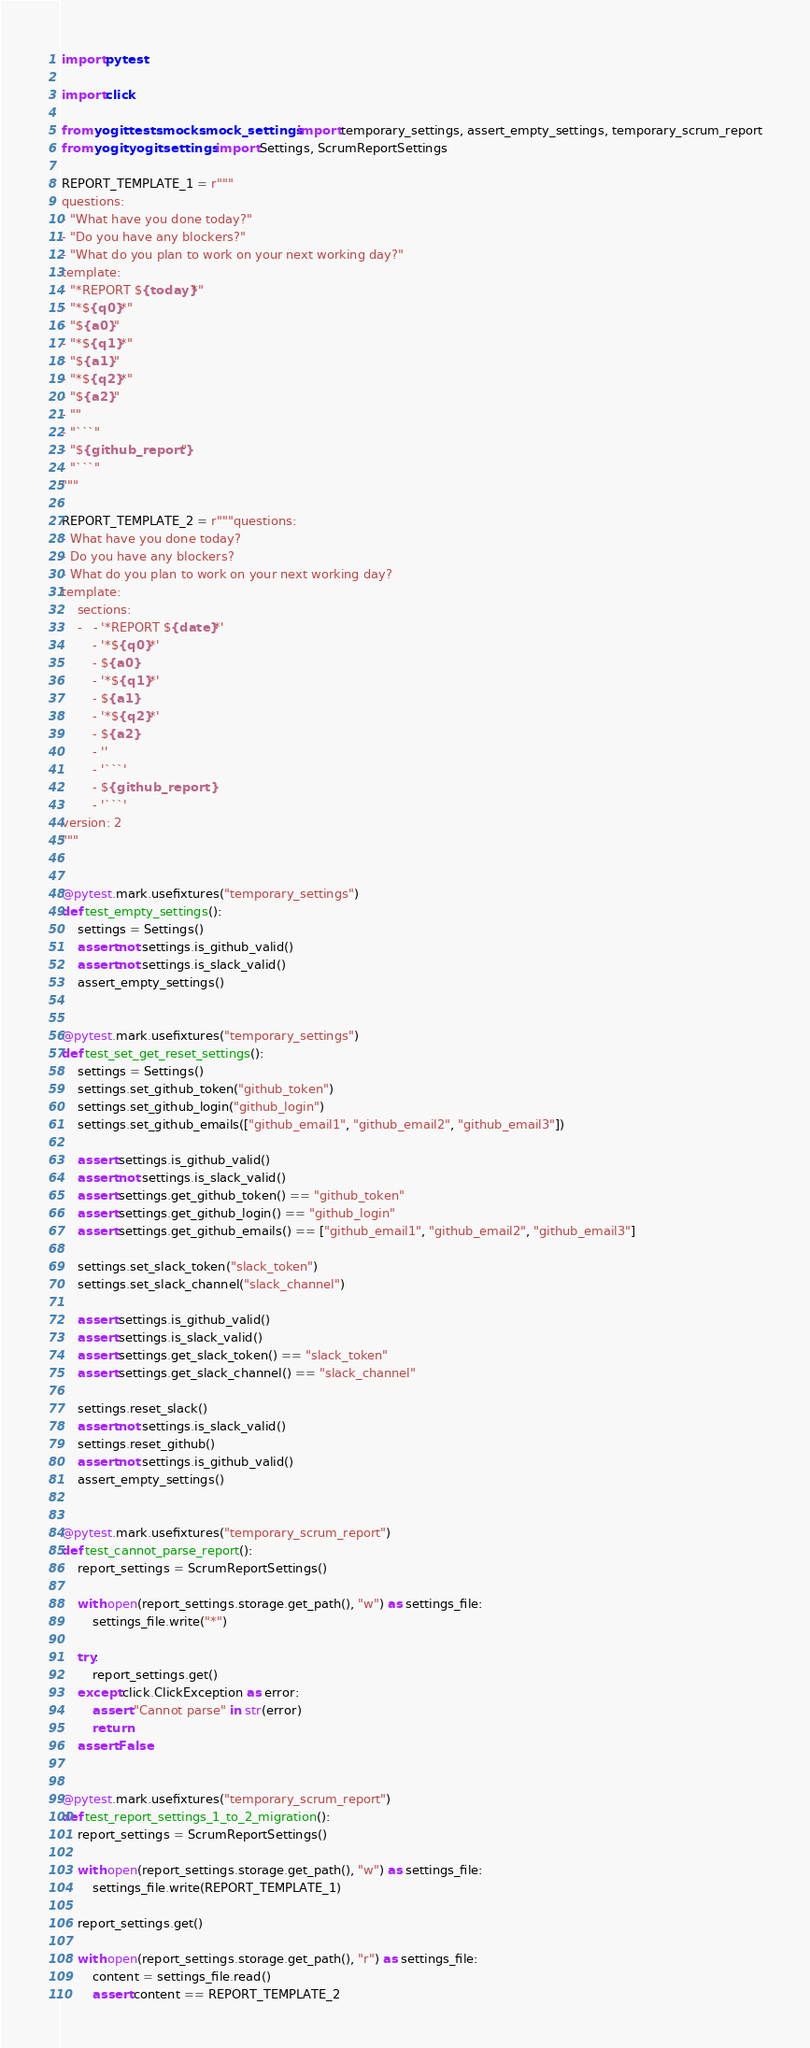Convert code to text. <code><loc_0><loc_0><loc_500><loc_500><_Python_>import pytest

import click

from yogit.tests.mocks.mock_settings import temporary_settings, assert_empty_settings, temporary_scrum_report
from yogit.yogit.settings import Settings, ScrumReportSettings

REPORT_TEMPLATE_1 = r"""
questions:
- "What have you done today?"
- "Do you have any blockers?"
- "What do you plan to work on your next working day?"
template:
- "*REPORT ${today}*"
- "*${q0}*"
- "${a0}"
- "*${q1}*"
- "${a1}"
- "*${q2}*"
- "${a2}"
- ""
- "```"
- "${github_report}"
- "```"
"""

REPORT_TEMPLATE_2 = r"""questions:
- What have you done today?
- Do you have any blockers?
- What do you plan to work on your next working day?
template:
    sections:
    -   - '*REPORT ${date}*'
        - '*${q0}*'
        - ${a0}
        - '*${q1}*'
        - ${a1}
        - '*${q2}*'
        - ${a2}
        - ''
        - '```'
        - ${github_report}
        - '```'
version: 2
"""


@pytest.mark.usefixtures("temporary_settings")
def test_empty_settings():
    settings = Settings()
    assert not settings.is_github_valid()
    assert not settings.is_slack_valid()
    assert_empty_settings()


@pytest.mark.usefixtures("temporary_settings")
def test_set_get_reset_settings():
    settings = Settings()
    settings.set_github_token("github_token")
    settings.set_github_login("github_login")
    settings.set_github_emails(["github_email1", "github_email2", "github_email3"])

    assert settings.is_github_valid()
    assert not settings.is_slack_valid()
    assert settings.get_github_token() == "github_token"
    assert settings.get_github_login() == "github_login"
    assert settings.get_github_emails() == ["github_email1", "github_email2", "github_email3"]

    settings.set_slack_token("slack_token")
    settings.set_slack_channel("slack_channel")

    assert settings.is_github_valid()
    assert settings.is_slack_valid()
    assert settings.get_slack_token() == "slack_token"
    assert settings.get_slack_channel() == "slack_channel"

    settings.reset_slack()
    assert not settings.is_slack_valid()
    settings.reset_github()
    assert not settings.is_github_valid()
    assert_empty_settings()


@pytest.mark.usefixtures("temporary_scrum_report")
def test_cannot_parse_report():
    report_settings = ScrumReportSettings()

    with open(report_settings.storage.get_path(), "w") as settings_file:
        settings_file.write("*")

    try:
        report_settings.get()
    except click.ClickException as error:
        assert "Cannot parse" in str(error)
        return
    assert False


@pytest.mark.usefixtures("temporary_scrum_report")
def test_report_settings_1_to_2_migration():
    report_settings = ScrumReportSettings()

    with open(report_settings.storage.get_path(), "w") as settings_file:
        settings_file.write(REPORT_TEMPLATE_1)

    report_settings.get()

    with open(report_settings.storage.get_path(), "r") as settings_file:
        content = settings_file.read()
        assert content == REPORT_TEMPLATE_2
</code> 